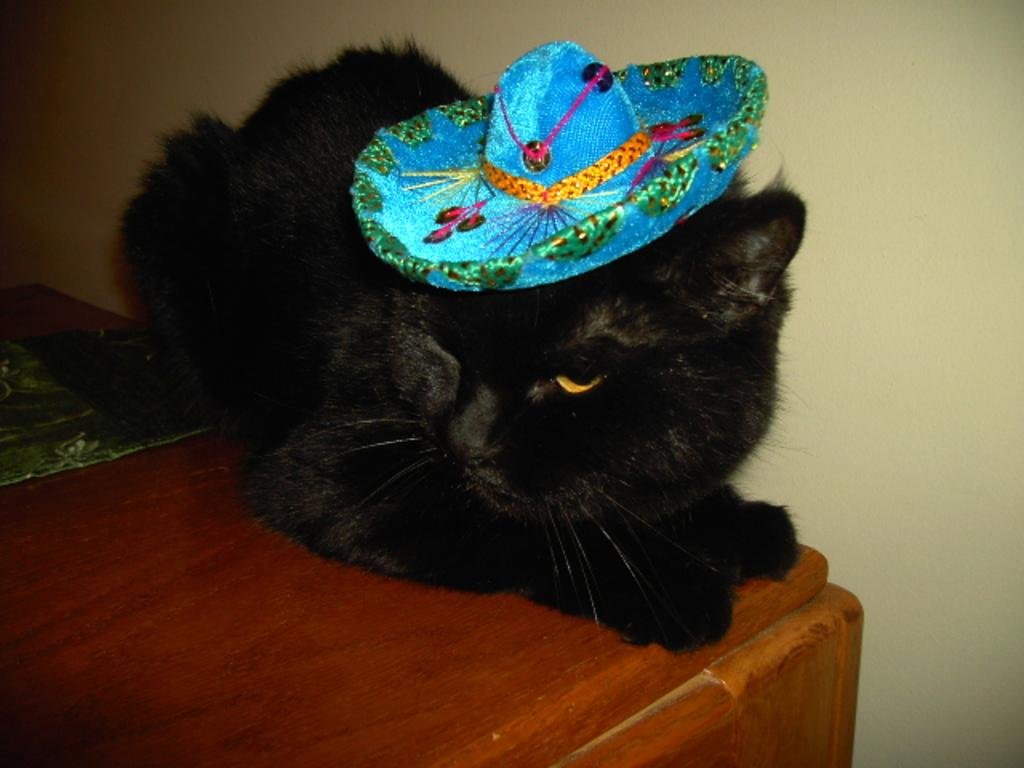What type of animal is in the image? There is a cat in the image. What is the cat sitting on? The cat is on a wooden surface. What accessory is the cat wearing? The cat is wearing a hat. What can be seen behind the cat? There is a wall visible in the image. What type of line is the cat using to read the book in the image? There is no book present in the image, and the cat is not reading. 